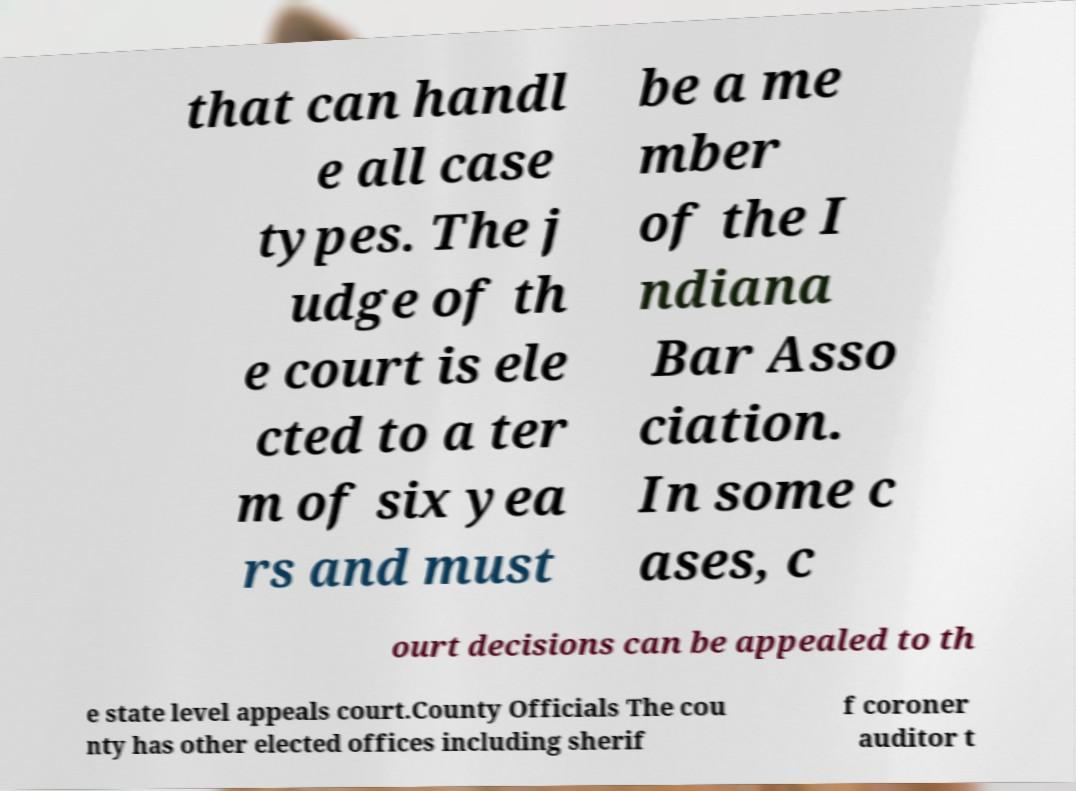Could you assist in decoding the text presented in this image and type it out clearly? that can handl e all case types. The j udge of th e court is ele cted to a ter m of six yea rs and must be a me mber of the I ndiana Bar Asso ciation. In some c ases, c ourt decisions can be appealed to th e state level appeals court.County Officials The cou nty has other elected offices including sherif f coroner auditor t 